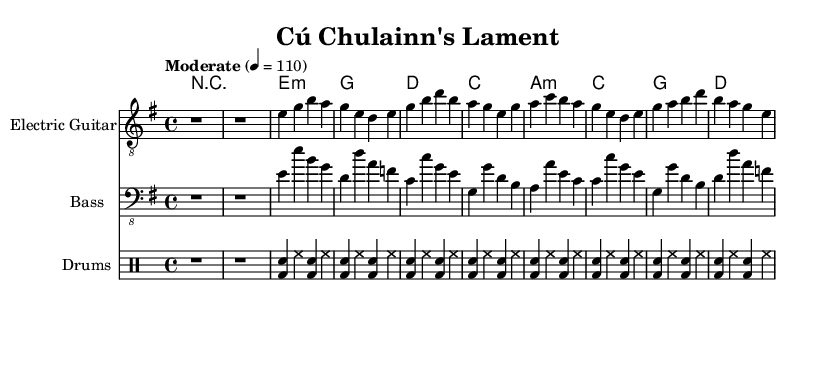What is the key signature of this music? The key signature is E minor, indicated by the presence of one sharp (F#).
Answer: E minor What is the time signature of the piece? The time signature is 4/4, shown at the beginning of the sheet music.
Answer: 4/4 What is the tempo marking? The tempo marking indicates a moderate speed of 110 beats per minute.
Answer: 110 What chord is played during the chorus? The chords for the chorus are Am, C, G, and D, as listed under the chord names section.
Answer: Am, C, G, D How many measures are in the verse section? The verse consists of 4 measures, which can be counted from the musical notation provided.
Answer: 4 Which instrument is the main melodic focus in this piece? The main melodic focus is on the Electric Guitar, as it carries the primary melody throughout the song.
Answer: Electric Guitar What style of music does this piece represent? The piece represents Electric Blues-Rock Fusion, as indicated by the genre and the instrumentation used within the composition.
Answer: Electric Blues-Rock Fusion 